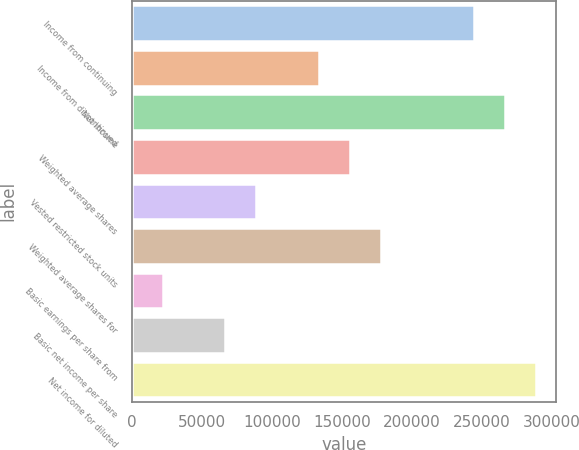Convert chart to OTSL. <chart><loc_0><loc_0><loc_500><loc_500><bar_chart><fcel>Income from continuing<fcel>Income from discontinued<fcel>Net income<fcel>Weighted average shares<fcel>Vested restricted stock units<fcel>Weighted average shares for<fcel>Basic earnings per share from<fcel>Basic net income per share<fcel>Net income for diluted<nl><fcel>244479<fcel>133353<fcel>266704<fcel>155578<fcel>88902.8<fcel>177804<fcel>22227.2<fcel>66677.6<fcel>288930<nl></chart> 